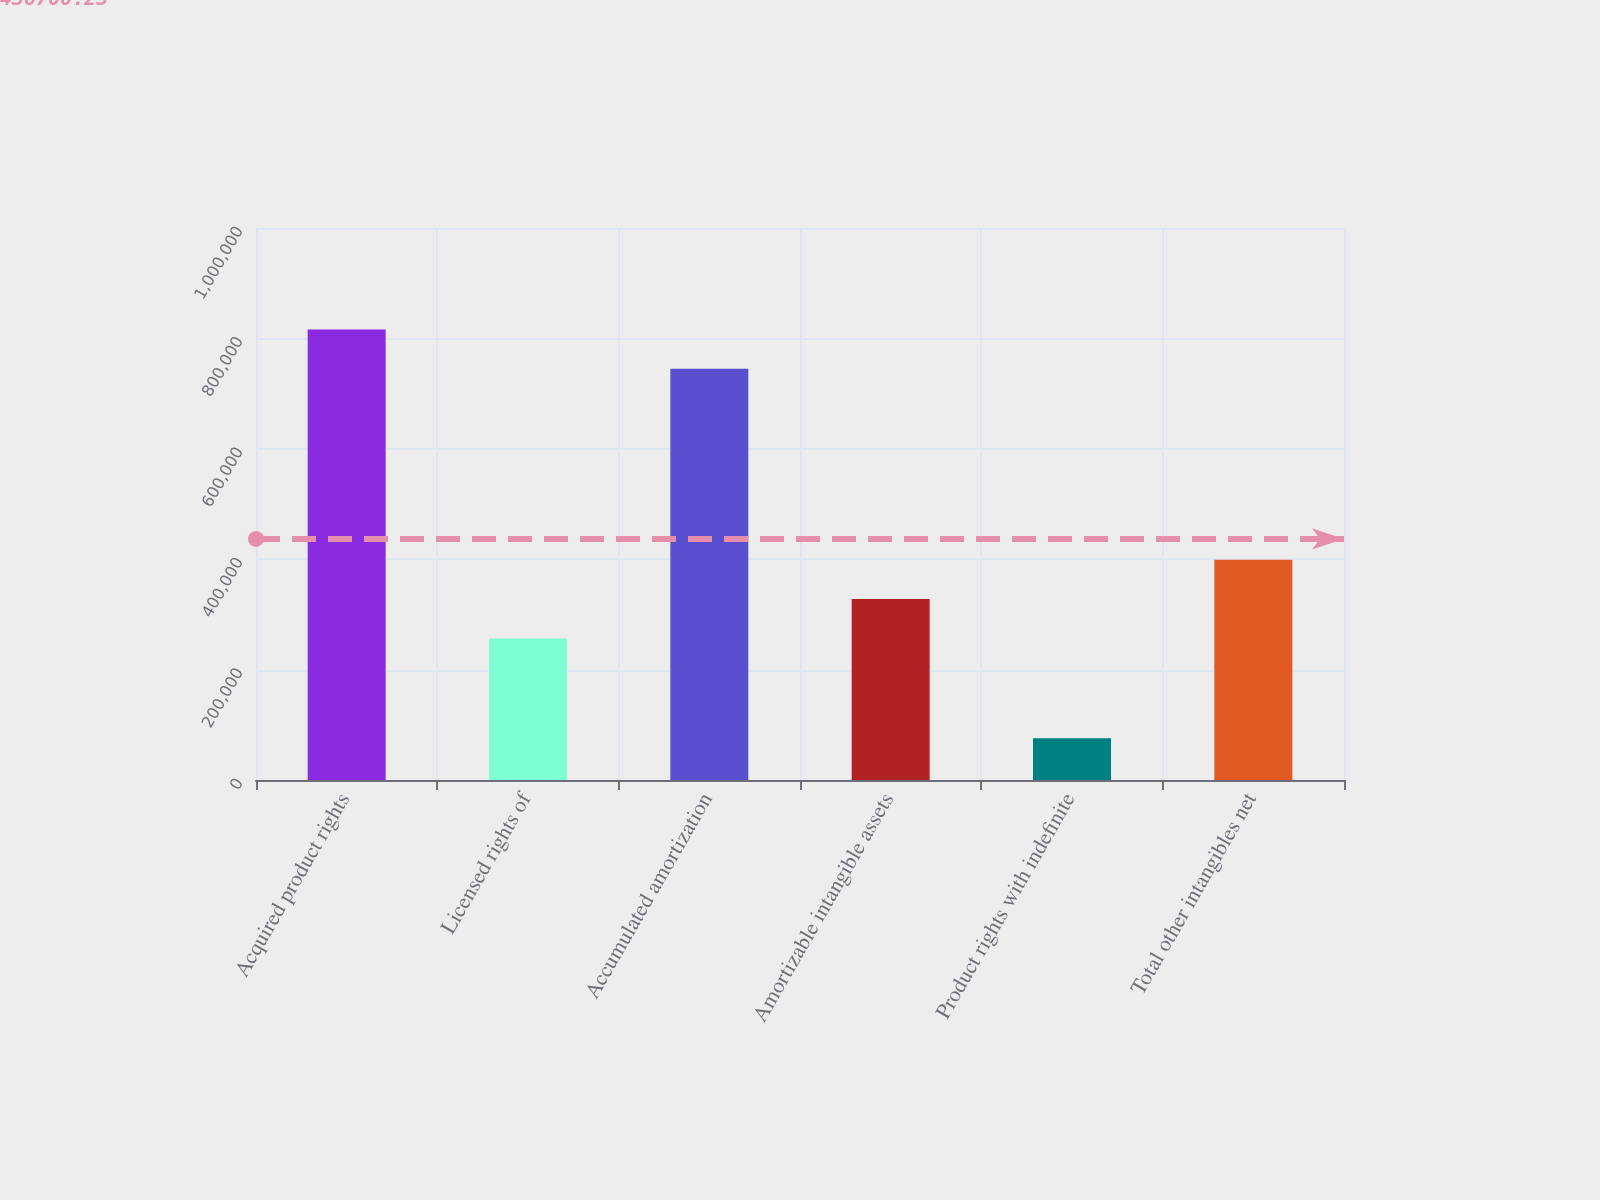Convert chart. <chart><loc_0><loc_0><loc_500><loc_500><bar_chart><fcel>Acquired product rights<fcel>Licensed rights of<fcel>Accumulated amortization<fcel>Amortizable intangible assets<fcel>Product rights with indefinite<fcel>Total other intangibles net<nl><fcel>816119<fcel>256555<fcel>744838<fcel>327836<fcel>75738<fcel>399116<nl></chart> 